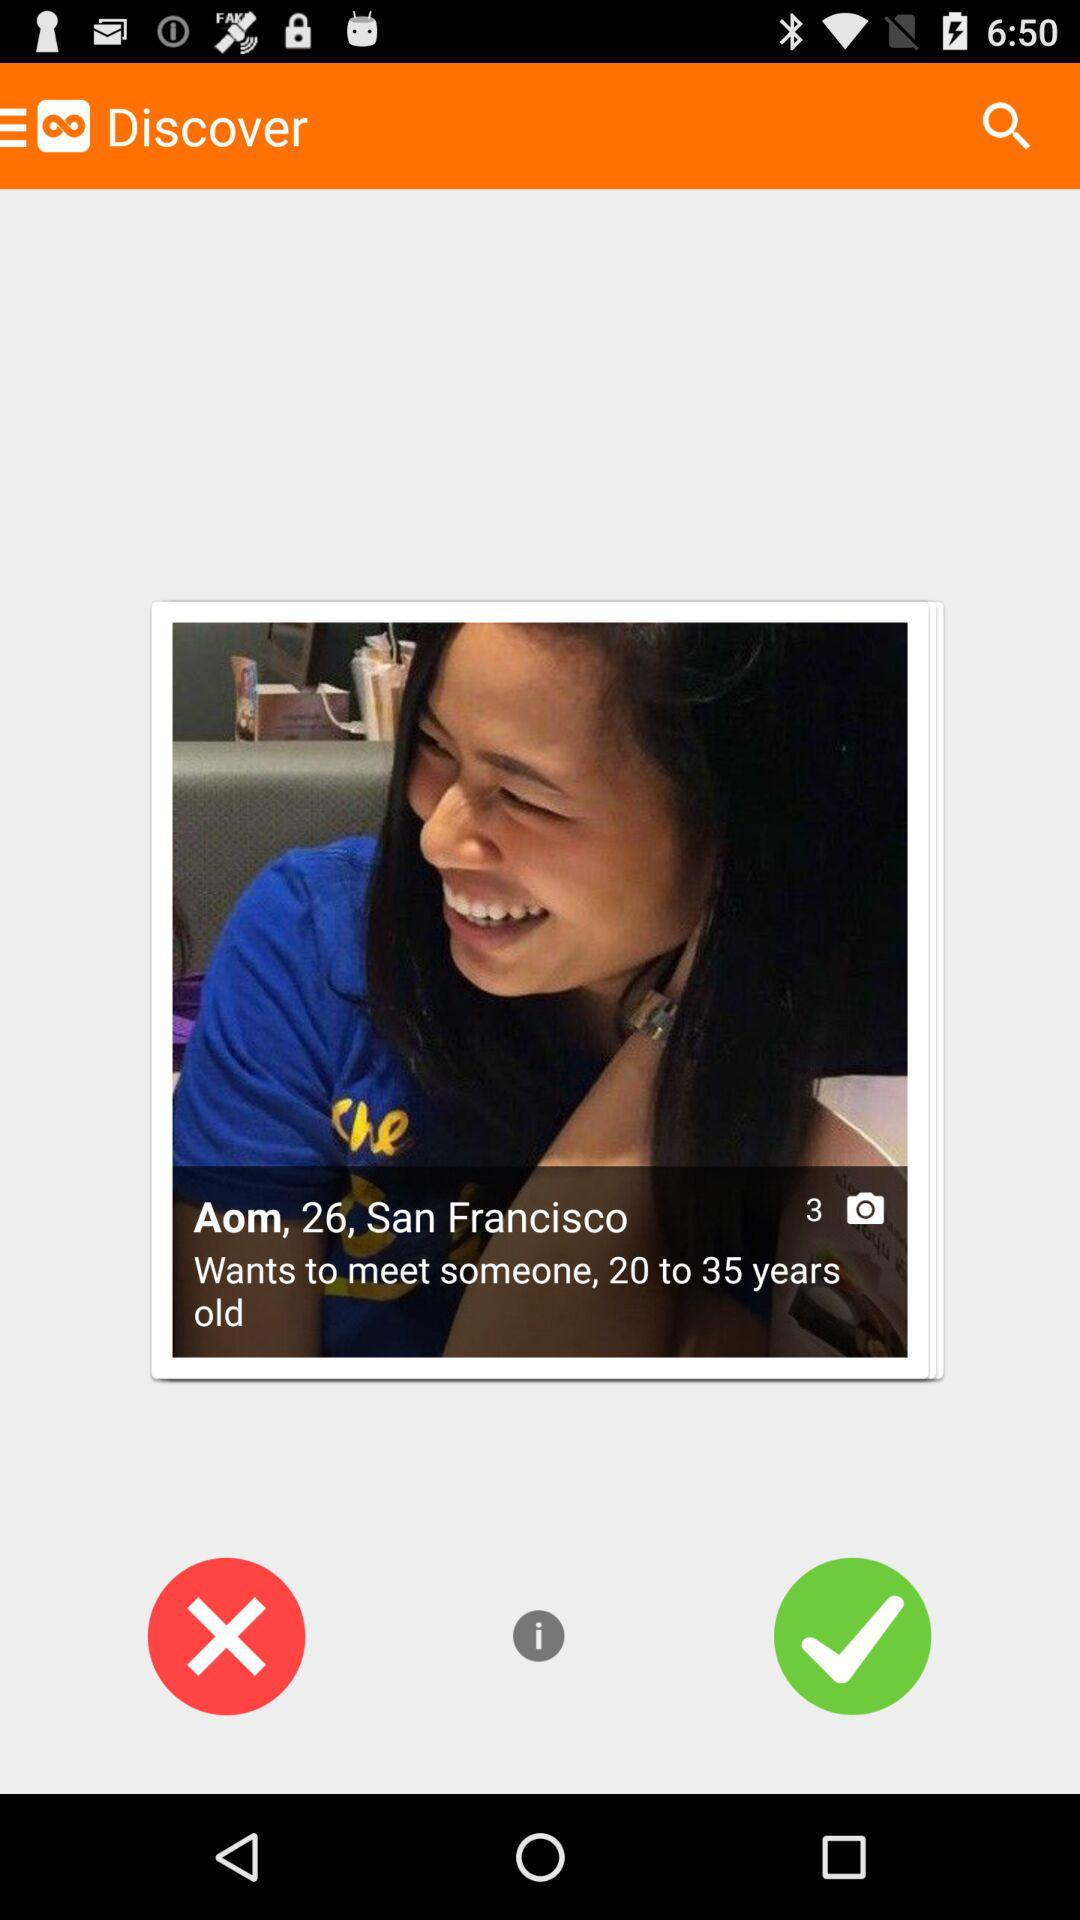How many photos does Aom have in the account? Aom has 3 photos in the account. 